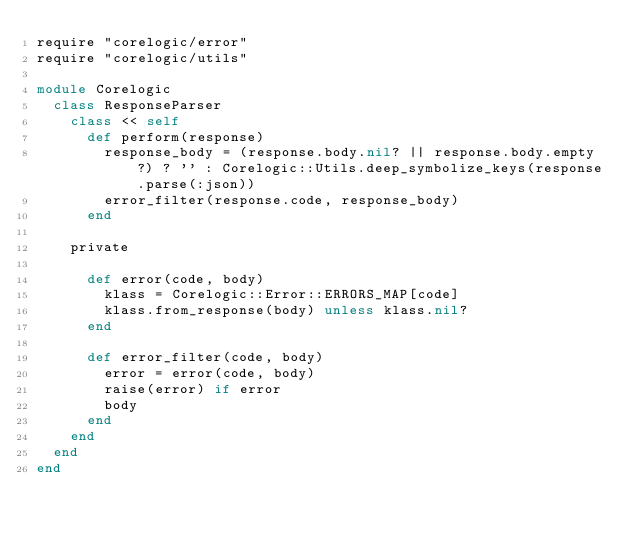<code> <loc_0><loc_0><loc_500><loc_500><_Ruby_>require "corelogic/error"
require "corelogic/utils"

module Corelogic
  class ResponseParser
    class << self
      def perform(response)
        response_body = (response.body.nil? || response.body.empty?) ? '' : Corelogic::Utils.deep_symbolize_keys(response.parse(:json))
        error_filter(response.code, response_body)
      end

    private

      def error(code, body)
        klass = Corelogic::Error::ERRORS_MAP[code]
        klass.from_response(body) unless klass.nil?
      end

      def error_filter(code, body)
        error = error(code, body)
        raise(error) if error
        body
      end
    end
  end
end

</code> 